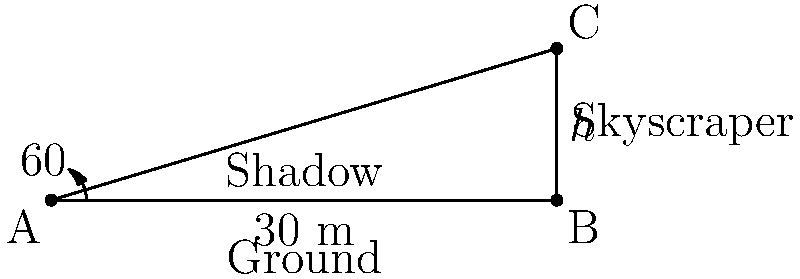As you critically analyze a newly constructed skyscraper, you decide to calculate its height using the principles of trigonometry, challenging the reliance on virtual measurements. If the skyscraper casts a shadow 30 meters long when the angle of elevation of the sun is 60°, what is the height of the skyscraper to the nearest meter? Let's approach this step-by-step:

1) In the right triangle formed by the skyscraper, its shadow, and the sun's rays, we know:
   - The length of the shadow (adjacent side) = 30 meters
   - The angle of elevation = 60°

2) We need to find the height of the skyscraper, which is the opposite side in this triangle.

3) The trigonometric ratio that relates the opposite side to the adjacent side is the tangent:

   $\tan \theta = \frac{\text{opposite}}{\text{adjacent}}$

4) In our case:

   $\tan 60° = \frac{\text{height}}{30}$

5) We know that $\tan 60° = \sqrt{3}$, so we can write:

   $\sqrt{3} = \frac{\text{height}}{30}$

6) To solve for the height:

   $\text{height} = 30 \sqrt{3}$

7) Calculate:
   $30 \sqrt{3} \approx 51.96$ meters

8) Rounding to the nearest meter:

   Height ≈ 52 meters
Answer: 52 meters 